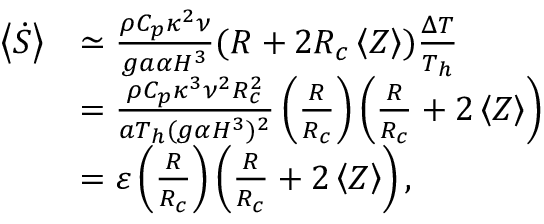Convert formula to latex. <formula><loc_0><loc_0><loc_500><loc_500>\begin{array} { r l } { \left < \dot { S } \right > } & { \simeq \frac { \rho C _ { p } \kappa ^ { 2 } \nu } { g a \alpha H ^ { 3 } } ( R + 2 R _ { c } \left < Z \right > ) \frac { \Delta T } { T _ { h } } } \\ & { = \frac { \rho C _ { p } \kappa ^ { 3 } \nu ^ { 2 } R _ { c } ^ { 2 } } { a T _ { h } ( g \alpha H ^ { 3 } ) ^ { 2 } } \left ( \frac { R } { R _ { c } } \right ) \left ( \frac { R } { R _ { c } } + 2 \left < Z \right > \right ) } \\ & { = \varepsilon \left ( \frac { R } { R _ { c } } \right ) \left ( \frac { R } { R _ { c } } + 2 \left < Z \right > \right ) , } \end{array}</formula> 